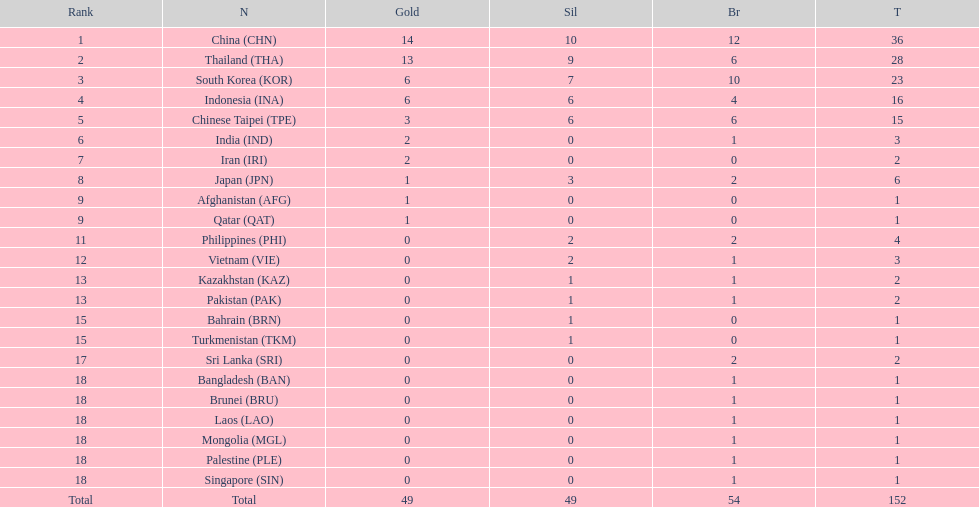How many nations won no silver medals at all? 11. 